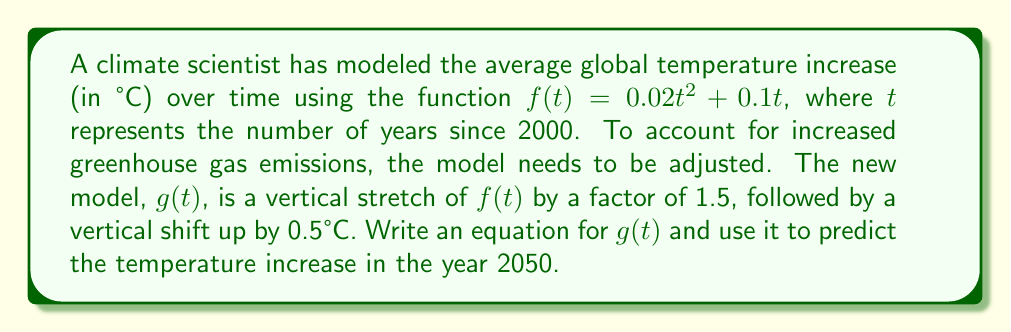Solve this math problem. 1. Start with the original function: $f(t) = 0.02t^2 + 0.1t$

2. Apply the vertical stretch by a factor of 1.5:
   $1.5f(t) = 1.5(0.02t^2 + 0.1t) = 0.03t^2 + 0.15t$

3. Apply the vertical shift up by 0.5°C:
   $g(t) = 1.5f(t) + 0.5 = (0.03t^2 + 0.15t) + 0.5 = 0.03t^2 + 0.15t + 0.5$

4. To predict the temperature increase in 2050, calculate $g(50)$ since 2050 is 50 years after 2000:
   $g(50) = 0.03(50)^2 + 0.15(50) + 0.5$
   $= 0.03(2500) + 7.5 + 0.5$
   $= 75 + 7.5 + 0.5$
   $= 83°C$

Therefore, the predicted temperature increase in 2050 is 83°C above the baseline temperature in 2000.
Answer: $g(t) = 0.03t^2 + 0.15t + 0.5$; 83°C 